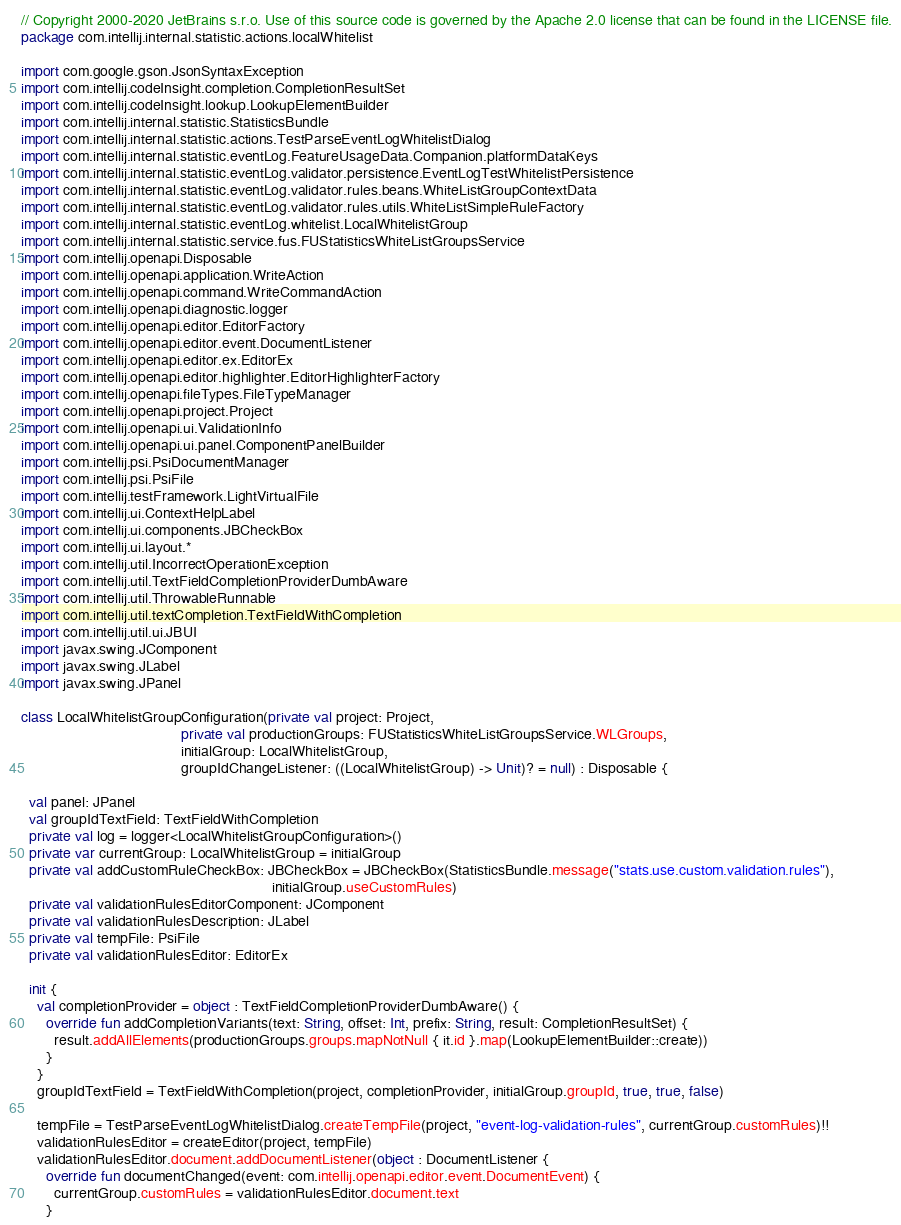Convert code to text. <code><loc_0><loc_0><loc_500><loc_500><_Kotlin_>// Copyright 2000-2020 JetBrains s.r.o. Use of this source code is governed by the Apache 2.0 license that can be found in the LICENSE file.
package com.intellij.internal.statistic.actions.localWhitelist

import com.google.gson.JsonSyntaxException
import com.intellij.codeInsight.completion.CompletionResultSet
import com.intellij.codeInsight.lookup.LookupElementBuilder
import com.intellij.internal.statistic.StatisticsBundle
import com.intellij.internal.statistic.actions.TestParseEventLogWhitelistDialog
import com.intellij.internal.statistic.eventLog.FeatureUsageData.Companion.platformDataKeys
import com.intellij.internal.statistic.eventLog.validator.persistence.EventLogTestWhitelistPersistence
import com.intellij.internal.statistic.eventLog.validator.rules.beans.WhiteListGroupContextData
import com.intellij.internal.statistic.eventLog.validator.rules.utils.WhiteListSimpleRuleFactory
import com.intellij.internal.statistic.eventLog.whitelist.LocalWhitelistGroup
import com.intellij.internal.statistic.service.fus.FUStatisticsWhiteListGroupsService
import com.intellij.openapi.Disposable
import com.intellij.openapi.application.WriteAction
import com.intellij.openapi.command.WriteCommandAction
import com.intellij.openapi.diagnostic.logger
import com.intellij.openapi.editor.EditorFactory
import com.intellij.openapi.editor.event.DocumentListener
import com.intellij.openapi.editor.ex.EditorEx
import com.intellij.openapi.editor.highlighter.EditorHighlighterFactory
import com.intellij.openapi.fileTypes.FileTypeManager
import com.intellij.openapi.project.Project
import com.intellij.openapi.ui.ValidationInfo
import com.intellij.openapi.ui.panel.ComponentPanelBuilder
import com.intellij.psi.PsiDocumentManager
import com.intellij.psi.PsiFile
import com.intellij.testFramework.LightVirtualFile
import com.intellij.ui.ContextHelpLabel
import com.intellij.ui.components.JBCheckBox
import com.intellij.ui.layout.*
import com.intellij.util.IncorrectOperationException
import com.intellij.util.TextFieldCompletionProviderDumbAware
import com.intellij.util.ThrowableRunnable
import com.intellij.util.textCompletion.TextFieldWithCompletion
import com.intellij.util.ui.JBUI
import javax.swing.JComponent
import javax.swing.JLabel
import javax.swing.JPanel

class LocalWhitelistGroupConfiguration(private val project: Project,
                                       private val productionGroups: FUStatisticsWhiteListGroupsService.WLGroups,
                                       initialGroup: LocalWhitelistGroup,
                                       groupIdChangeListener: ((LocalWhitelistGroup) -> Unit)? = null) : Disposable {

  val panel: JPanel
  val groupIdTextField: TextFieldWithCompletion
  private val log = logger<LocalWhitelistGroupConfiguration>()
  private var currentGroup: LocalWhitelistGroup = initialGroup
  private val addCustomRuleCheckBox: JBCheckBox = JBCheckBox(StatisticsBundle.message("stats.use.custom.validation.rules"),
                                                             initialGroup.useCustomRules)
  private val validationRulesEditorComponent: JComponent
  private val validationRulesDescription: JLabel
  private val tempFile: PsiFile
  private val validationRulesEditor: EditorEx

  init {
    val completionProvider = object : TextFieldCompletionProviderDumbAware() {
      override fun addCompletionVariants(text: String, offset: Int, prefix: String, result: CompletionResultSet) {
        result.addAllElements(productionGroups.groups.mapNotNull { it.id }.map(LookupElementBuilder::create))
      }
    }
    groupIdTextField = TextFieldWithCompletion(project, completionProvider, initialGroup.groupId, true, true, false)

    tempFile = TestParseEventLogWhitelistDialog.createTempFile(project, "event-log-validation-rules", currentGroup.customRules)!!
    validationRulesEditor = createEditor(project, tempFile)
    validationRulesEditor.document.addDocumentListener(object : DocumentListener {
      override fun documentChanged(event: com.intellij.openapi.editor.event.DocumentEvent) {
        currentGroup.customRules = validationRulesEditor.document.text
      }</code> 